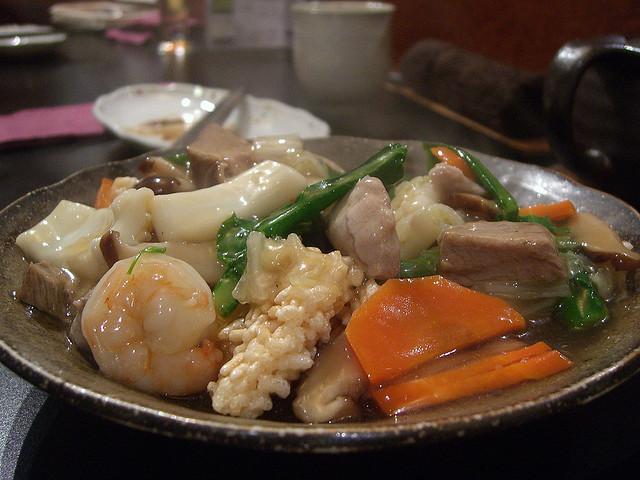Does this meal look healthy?
Concise answer only. Yes. Which vegetables are sliced the narrowest?
Write a very short answer. Carrots. How many shrimp can you see on the plate?
Be succinct. 1. Can you have this with rice?
Concise answer only. Yes. 